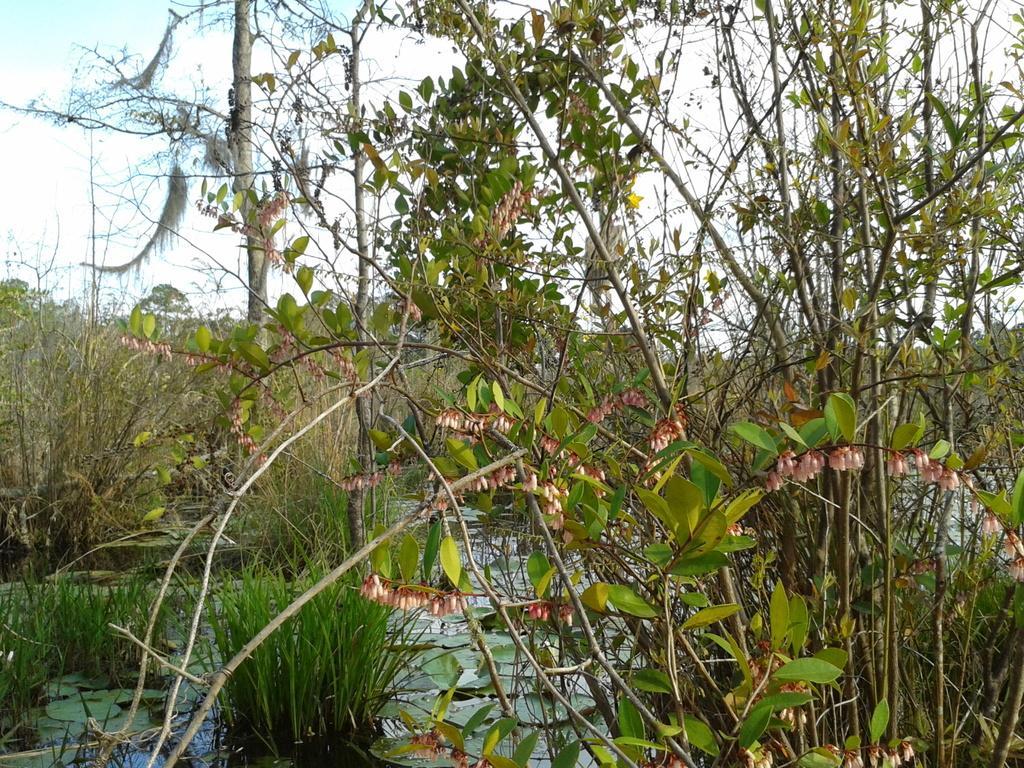In one or two sentences, can you explain what this image depicts? In this picture we can see trees, at the bottom there is some grass and some leaves, we can see sky at the top of the picture. 